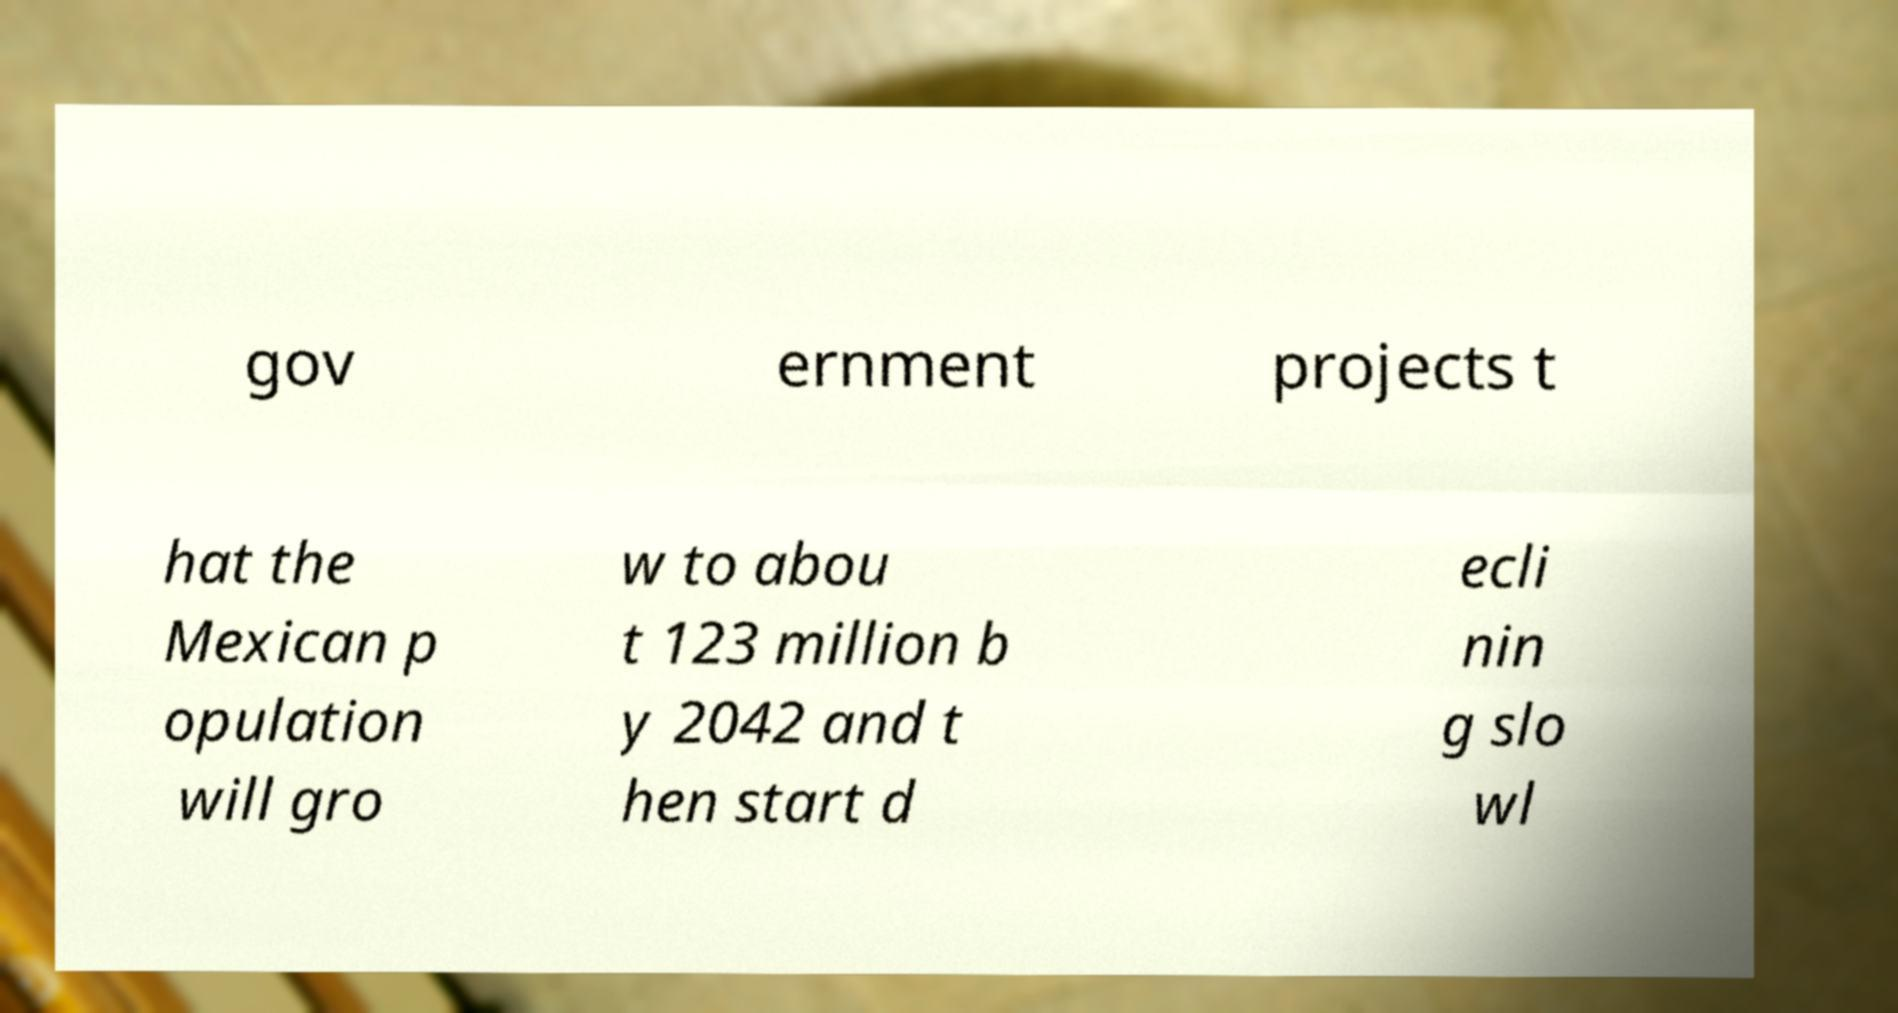For documentation purposes, I need the text within this image transcribed. Could you provide that? gov ernment projects t hat the Mexican p opulation will gro w to abou t 123 million b y 2042 and t hen start d ecli nin g slo wl 